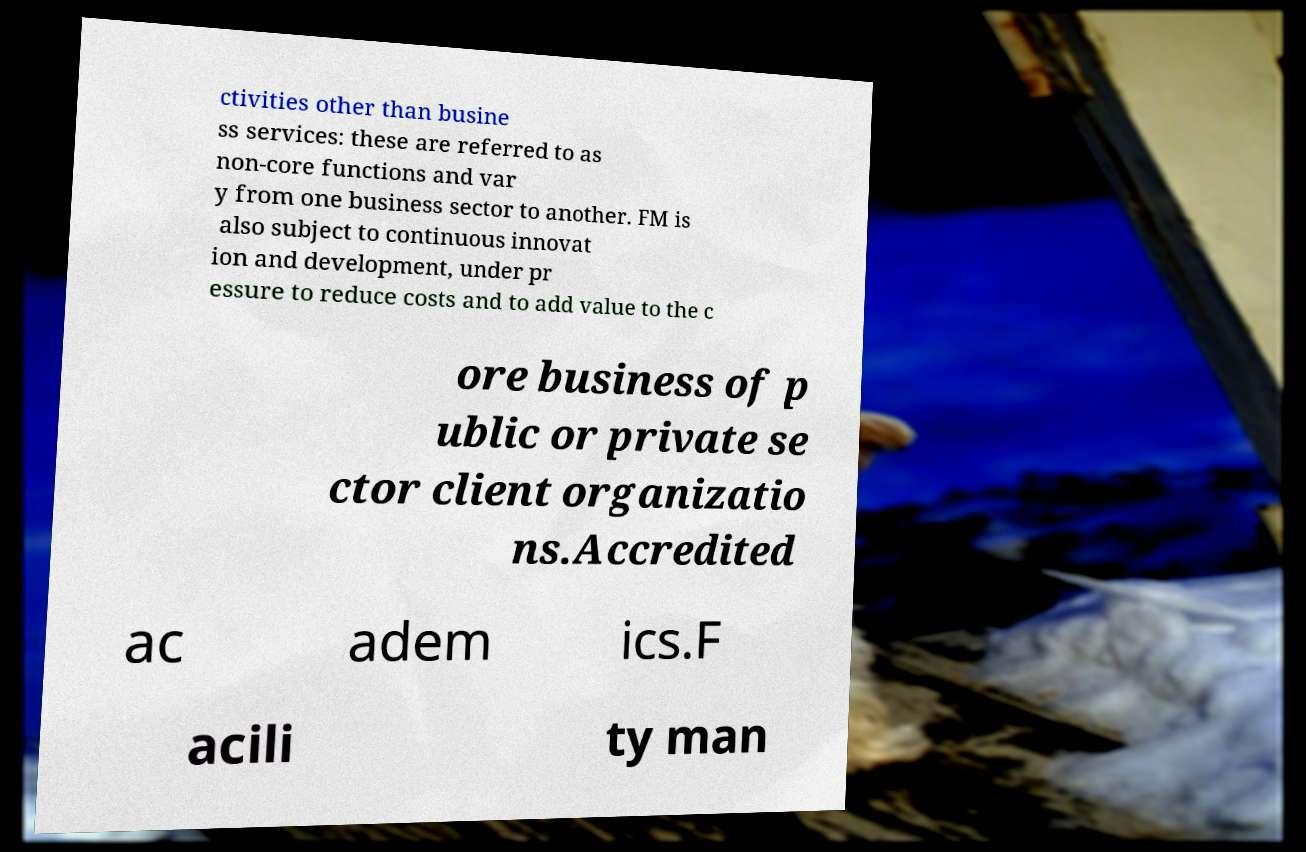For documentation purposes, I need the text within this image transcribed. Could you provide that? ctivities other than busine ss services: these are referred to as non-core functions and var y from one business sector to another. FM is also subject to continuous innovat ion and development, under pr essure to reduce costs and to add value to the c ore business of p ublic or private se ctor client organizatio ns.Accredited ac adem ics.F acili ty man 